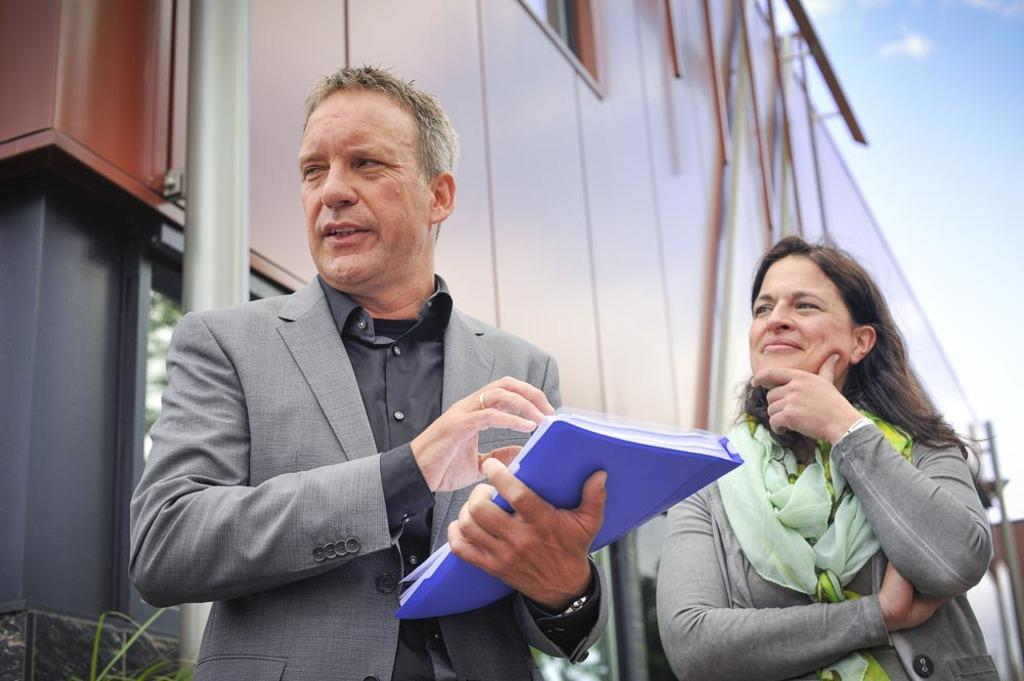How many people are present in the image? There are two people in the image. Can you describe the position of the man in the image? The man is standing in the center of the image. What is the man holding in the image? The man is holding a book. What can be seen in the background of the image? There is a building and the sky visible in the background of the image. What type of stamp can be seen on the man's forehead in the image? There is no stamp visible on the man's forehead in the image. What is the name of the downtown area visible in the image? There is no downtown area visible in the image, only a building and the sky in the background. 